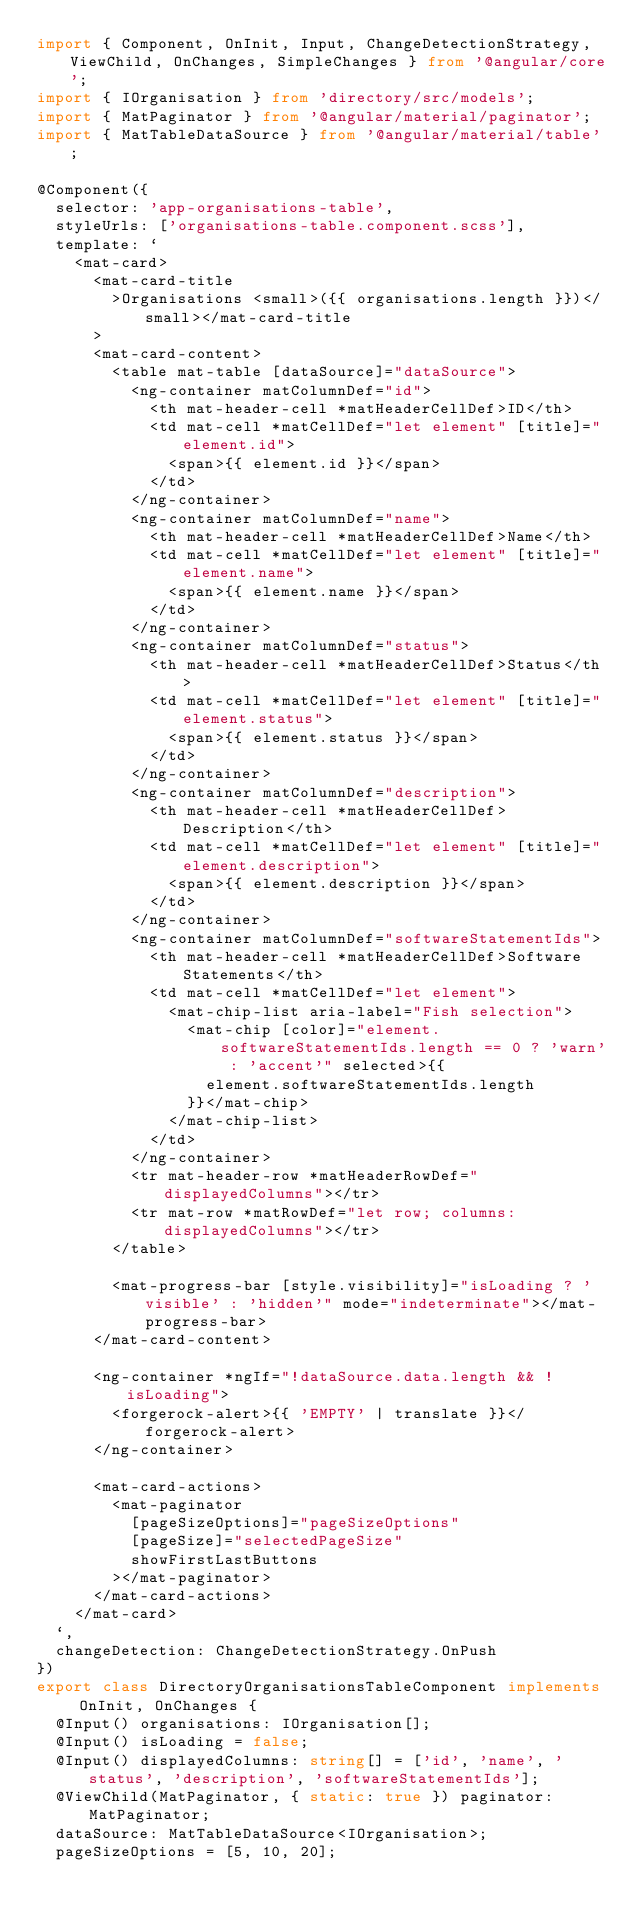<code> <loc_0><loc_0><loc_500><loc_500><_TypeScript_>import { Component, OnInit, Input, ChangeDetectionStrategy, ViewChild, OnChanges, SimpleChanges } from '@angular/core';
import { IOrganisation } from 'directory/src/models';
import { MatPaginator } from '@angular/material/paginator';
import { MatTableDataSource } from '@angular/material/table';

@Component({
  selector: 'app-organisations-table',
  styleUrls: ['organisations-table.component.scss'],
  template: `
    <mat-card>
      <mat-card-title
        >Organisations <small>({{ organisations.length }})</small></mat-card-title
      >
      <mat-card-content>
        <table mat-table [dataSource]="dataSource">
          <ng-container matColumnDef="id">
            <th mat-header-cell *matHeaderCellDef>ID</th>
            <td mat-cell *matCellDef="let element" [title]="element.id">
              <span>{{ element.id }}</span>
            </td>
          </ng-container>
          <ng-container matColumnDef="name">
            <th mat-header-cell *matHeaderCellDef>Name</th>
            <td mat-cell *matCellDef="let element" [title]="element.name">
              <span>{{ element.name }}</span>
            </td>
          </ng-container>
          <ng-container matColumnDef="status">
            <th mat-header-cell *matHeaderCellDef>Status</th>
            <td mat-cell *matCellDef="let element" [title]="element.status">
              <span>{{ element.status }}</span>
            </td>
          </ng-container>
          <ng-container matColumnDef="description">
            <th mat-header-cell *matHeaderCellDef>Description</th>
            <td mat-cell *matCellDef="let element" [title]="element.description">
              <span>{{ element.description }}</span>
            </td>
          </ng-container>
          <ng-container matColumnDef="softwareStatementIds">
            <th mat-header-cell *matHeaderCellDef>Software Statements</th>
            <td mat-cell *matCellDef="let element">
              <mat-chip-list aria-label="Fish selection">
                <mat-chip [color]="element.softwareStatementIds.length == 0 ? 'warn' : 'accent'" selected>{{
                  element.softwareStatementIds.length
                }}</mat-chip>
              </mat-chip-list>
            </td>
          </ng-container>
          <tr mat-header-row *matHeaderRowDef="displayedColumns"></tr>
          <tr mat-row *matRowDef="let row; columns: displayedColumns"></tr>
        </table>

        <mat-progress-bar [style.visibility]="isLoading ? 'visible' : 'hidden'" mode="indeterminate"></mat-progress-bar>
      </mat-card-content>

      <ng-container *ngIf="!dataSource.data.length && !isLoading">
        <forgerock-alert>{{ 'EMPTY' | translate }}</forgerock-alert>
      </ng-container>

      <mat-card-actions>
        <mat-paginator
          [pageSizeOptions]="pageSizeOptions"
          [pageSize]="selectedPageSize"
          showFirstLastButtons
        ></mat-paginator>
      </mat-card-actions>
    </mat-card>
  `,
  changeDetection: ChangeDetectionStrategy.OnPush
})
export class DirectoryOrganisationsTableComponent implements OnInit, OnChanges {
  @Input() organisations: IOrganisation[];
  @Input() isLoading = false;
  @Input() displayedColumns: string[] = ['id', 'name', 'status', 'description', 'softwareStatementIds'];
  @ViewChild(MatPaginator, { static: true }) paginator: MatPaginator;
  dataSource: MatTableDataSource<IOrganisation>;
  pageSizeOptions = [5, 10, 20];</code> 